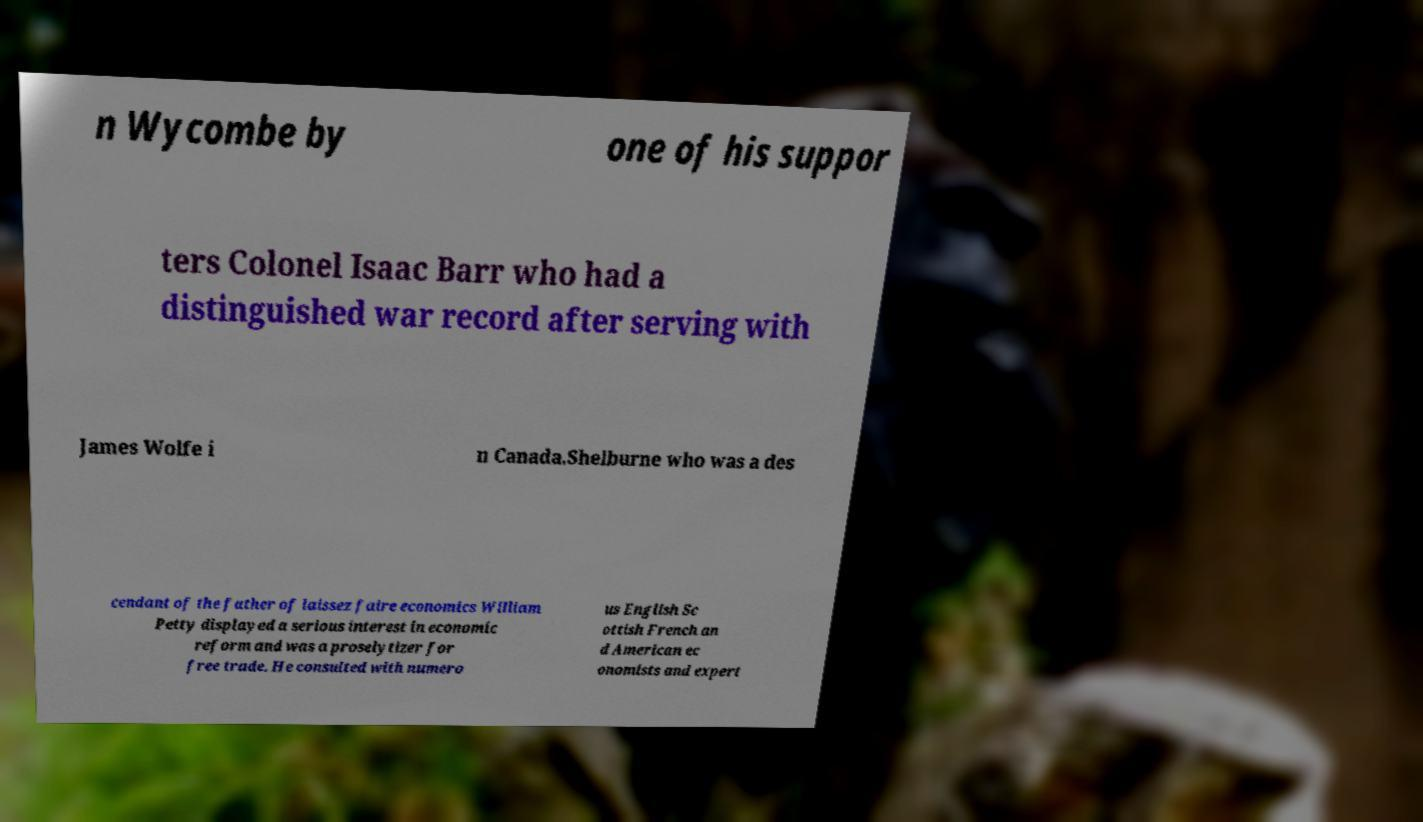Can you accurately transcribe the text from the provided image for me? n Wycombe by one of his suppor ters Colonel Isaac Barr who had a distinguished war record after serving with James Wolfe i n Canada.Shelburne who was a des cendant of the father of laissez faire economics William Petty displayed a serious interest in economic reform and was a proselytizer for free trade. He consulted with numero us English Sc ottish French an d American ec onomists and expert 